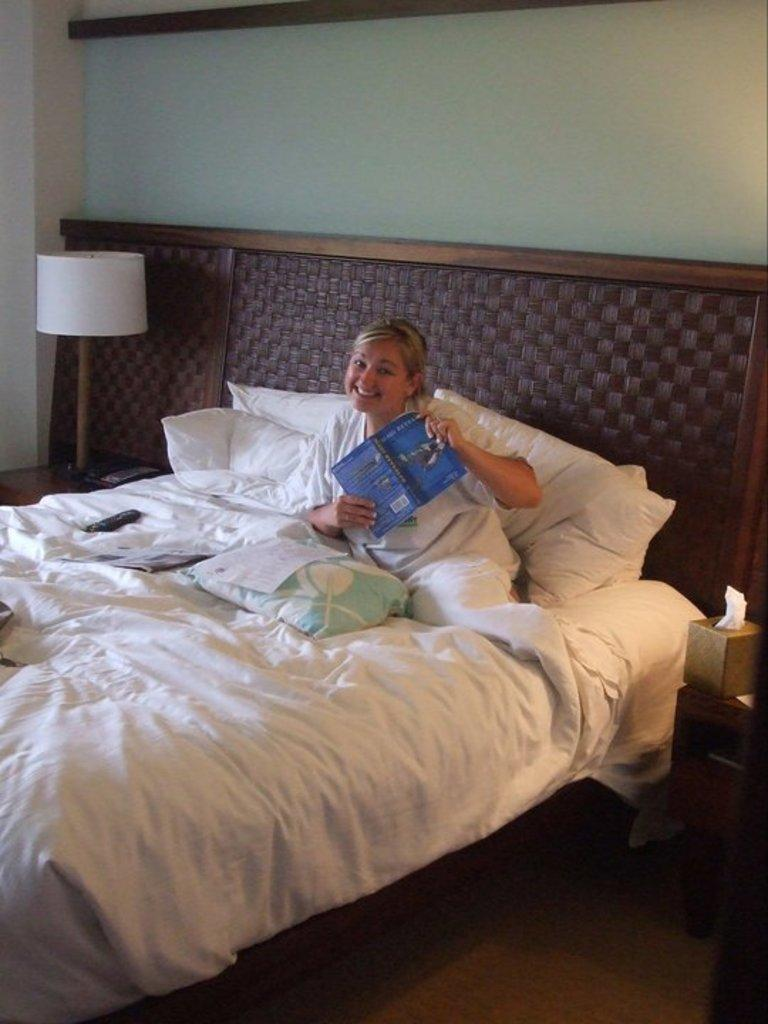What is the person in the image doing? The person is holding a book. Where is the person sitting in the image? The person is sitting on a bed. What might the person be doing with the book? The person might be reading or studying the book. What type of glass is the person drinking from in the image? There is no glass present in the image; the person is holding a book. 